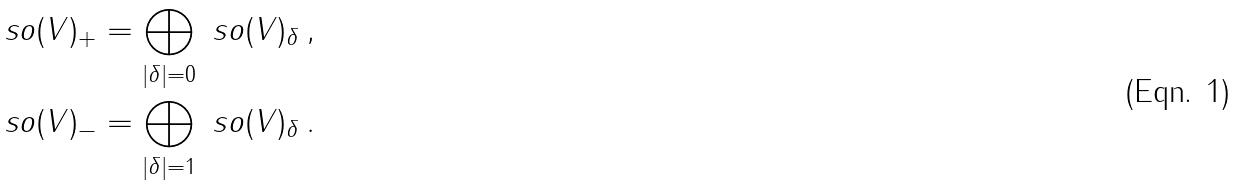Convert formula to latex. <formula><loc_0><loc_0><loc_500><loc_500>& \ s o ( V ) _ { + } = \bigoplus _ { | \delta | = 0 } \ s o ( V ) _ { \delta } \, , \\ & \ s o ( V ) _ { - } = \bigoplus _ { | \delta | = 1 } \ s o ( V ) _ { \delta } \, .</formula> 